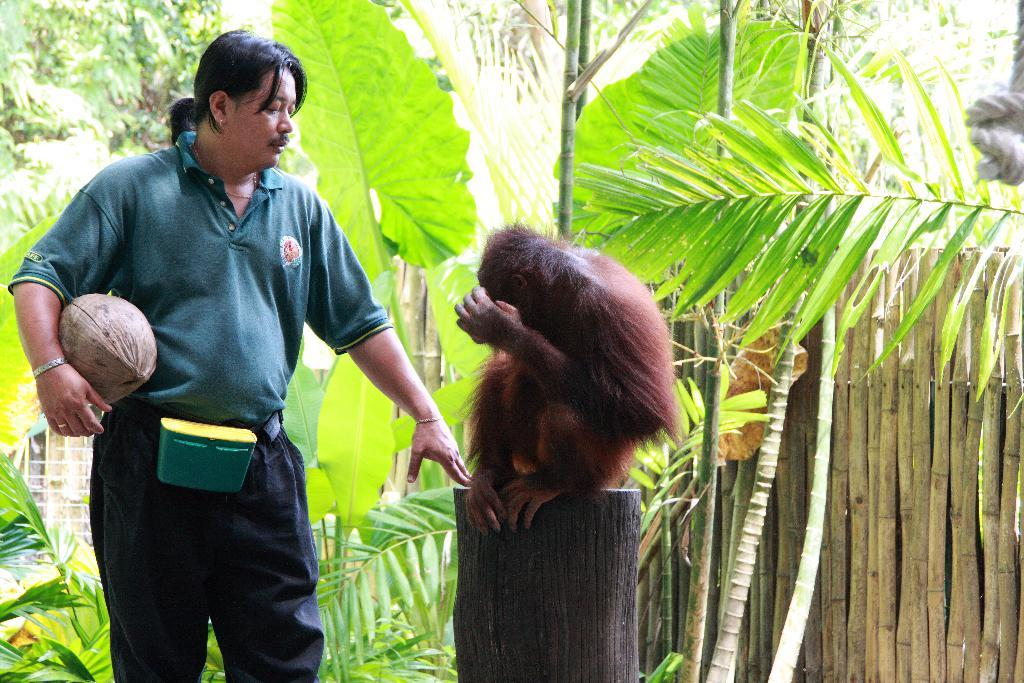What type of vegetation can be seen in the background of the image? There are trees in the background of the image. What animal is sitting on a branch in the image? There is a monkey sitting on a branch in the image. Who is standing beside the monkey in the image? There is a man standing beside the monkey in the image. What is the man holding in his hand in the image? The man is holding something in his hand in the image. How many cacti are visible in the image? There are no cacti visible in the image; only trees are mentioned in the background. What type of sticks can be seen in the image? There is no mention of sticks in the image; the focus is on the monkey, the man, and the objects they are holding. 